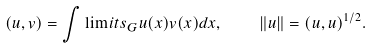<formula> <loc_0><loc_0><loc_500><loc_500>( u , v ) = \int \lim i t s _ { G } u ( x ) v ( x ) d x , \quad \| u \| = ( u , u ) ^ { 1 / 2 } .</formula> 